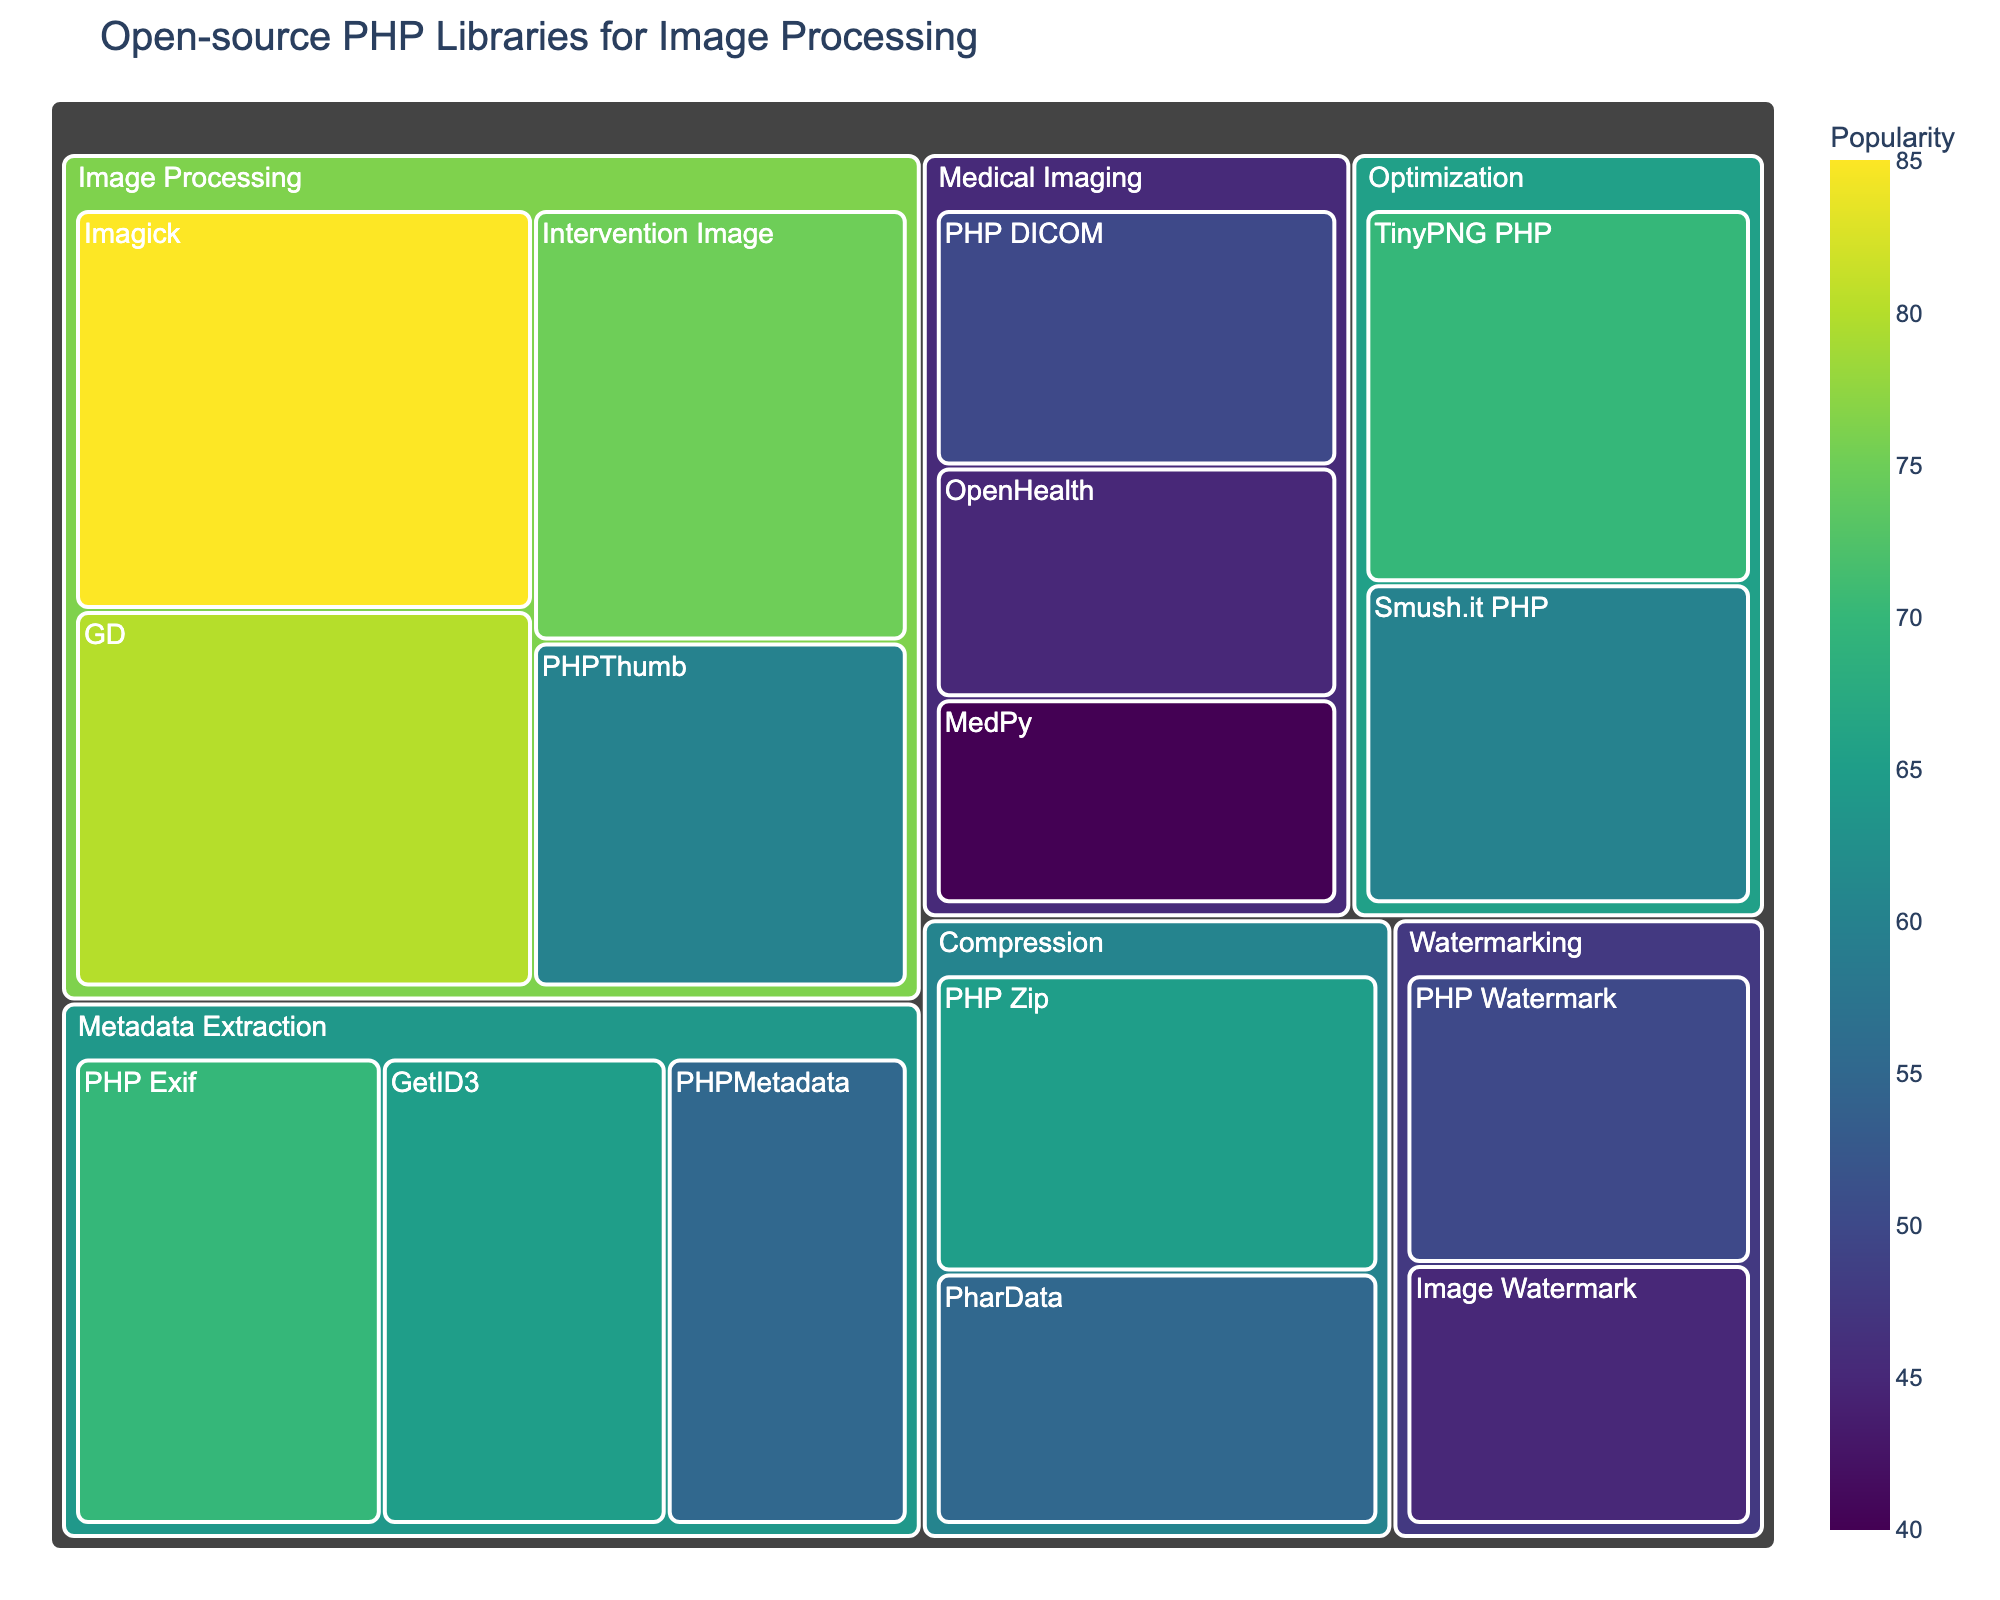What is the title of the treemap? The title of the treemap is usually displayed prominently at the top of the figure. By looking at the top section of the treemap, we can easily identify the title.
Answer: Open-source PHP Libraries for Image Processing Which library under the Metadata Extraction category has the highest popularity? Under the Metadata Extraction category, we need to compare the popularity values of the libraries listed. The library with the highest value is the one we are looking for.
Answer: PHP Exif What is the combined popularity of all the Medical Imaging libraries? To find the combined popularity, we need to sum the popularity values of all the libraries in the Medical Imaging category: PHP DICOM (50), OpenHealth (45), and MedPy (40). Therefore, 50 + 45 + 40 = 135.
Answer: 135 Which category has the most popular library overall? We look for the library with the highest popularity value in the entire figure and then identify its category. Imagick has the highest popularity value of 85, which belongs to the Image Processing category.
Answer: Image Processing Compare the popularity of Imagick and Interventions Image. Which library is more popular and by how much? First, identify the popularity values of Imagick (85) and Interventions Image (75). Then, subtract the smaller value from the larger value: 85 - 75 = 10. Imagick is more popular by 10 points.
Answer: Imagick, by 10 What is the average popularity of the libraries in the Compression category? To calculate the average, we sum the popularity values of the libraries in the Compression category (PHP Zip: 65, PharData: 55), which equals 120. Then, divide this by the number of libraries (2): 120 / 2 = 60.
Answer: 60 Which category contains the most libraries? By counting the number of libraries in each category, we notice that Image Processing has 4 libraries, Metadata Extraction has 3, Medical Imaging has 3, Compression has 2, Optimization has 2, and Watermarking has 2. Thus, Image Processing contains the most libraries.
Answer: Image Processing What is the least popular library in the figure? By examining the popularity values of all the libraries, we find that MedPy in the Medical Imaging category has the lowest popularity with a value of 40.
Answer: MedPy What is the popularity difference between the most popular and least popular libraries in the Watermarking category? The libraries in the Watermarking category are PHP Watermark (50) and Image Watermark (45). The difference in popularity is 50 - 45 = 5.
Answer: 5 